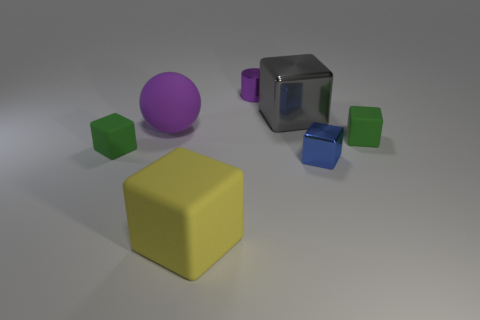Subtract all small blue cubes. How many cubes are left? 4 Subtract all cyan blocks. Subtract all yellow spheres. How many blocks are left? 5 Add 2 big metal blocks. How many objects exist? 9 Subtract all blocks. How many objects are left? 2 Add 2 balls. How many balls are left? 3 Add 4 big yellow cubes. How many big yellow cubes exist? 5 Subtract 0 blue cylinders. How many objects are left? 7 Subtract all gray blocks. Subtract all small green rubber cubes. How many objects are left? 4 